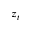Convert formula to latex. <formula><loc_0><loc_0><loc_500><loc_500>z _ { t }</formula> 